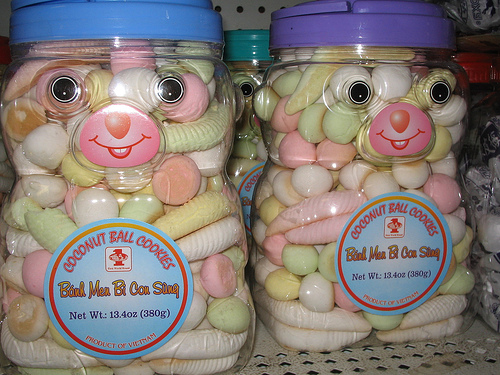<image>
Can you confirm if the jar is next to the jar? Yes. The jar is positioned adjacent to the jar, located nearby in the same general area. Where is the candy in relation to the cap? Is it under the cap? Yes. The candy is positioned underneath the cap, with the cap above it in the vertical space. Where is the cookies in relation to the cookies? Is it behind the cookies? No. The cookies is not behind the cookies. From this viewpoint, the cookies appears to be positioned elsewhere in the scene. 